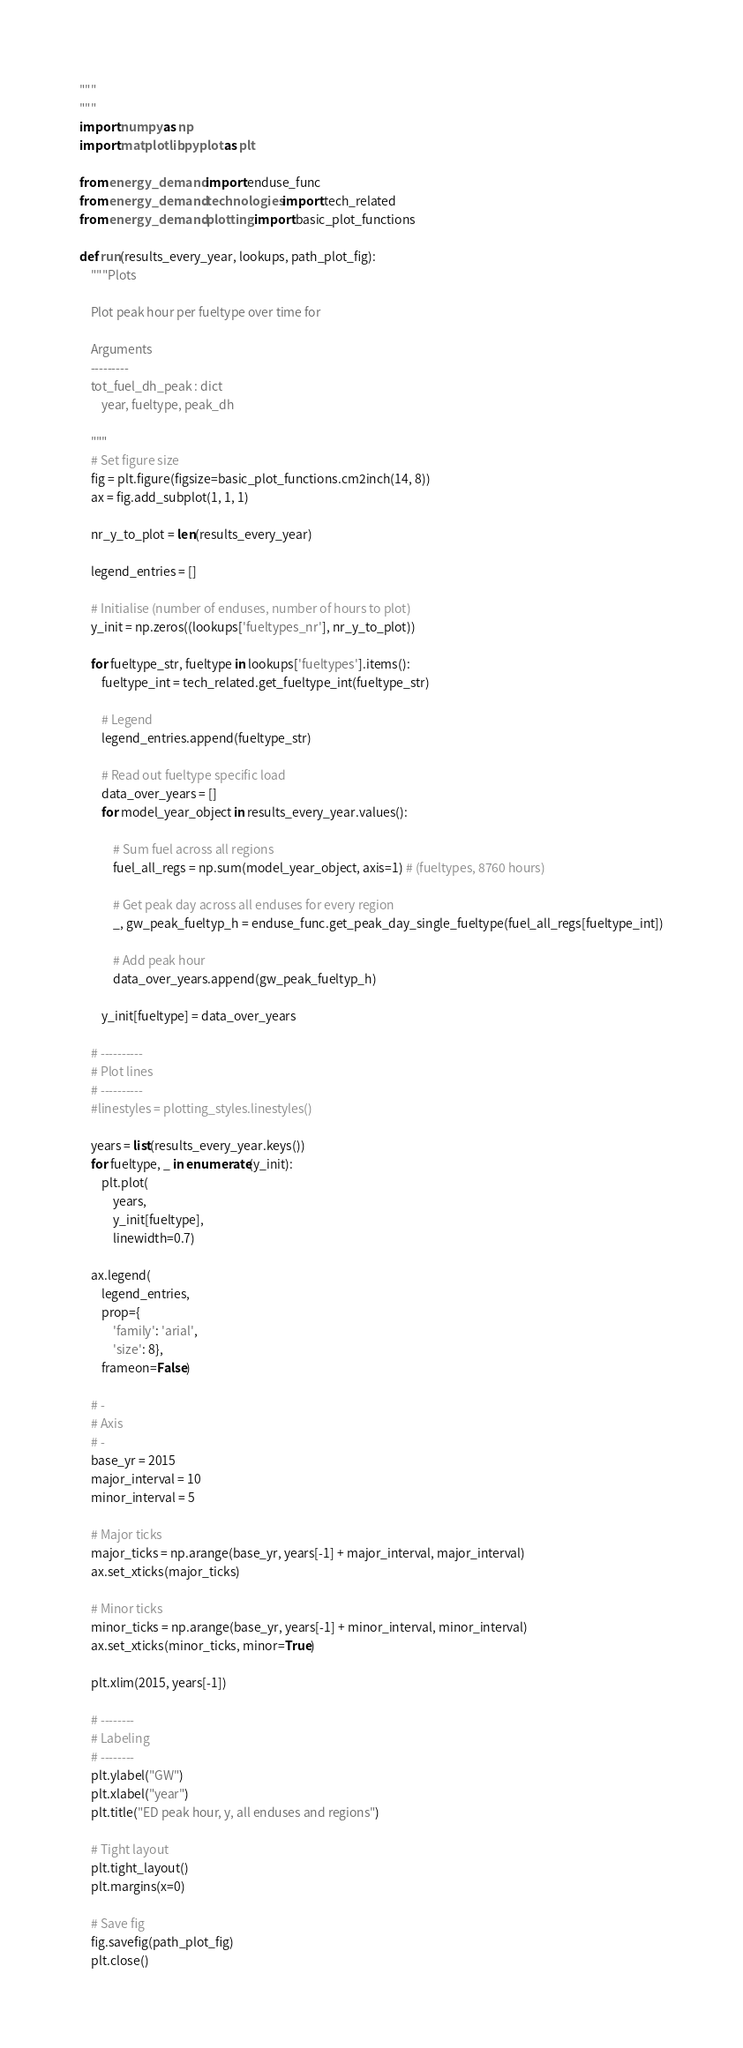Convert code to text. <code><loc_0><loc_0><loc_500><loc_500><_Python_>"""
"""
import numpy as np
import matplotlib.pyplot as plt

from energy_demand import enduse_func
from energy_demand.technologies import tech_related
from energy_demand.plotting import basic_plot_functions

def run(results_every_year, lookups, path_plot_fig):
    """Plots

    Plot peak hour per fueltype over time for

    Arguments
    ---------
    tot_fuel_dh_peak : dict
        year, fueltype, peak_dh

    """
    # Set figure size
    fig = plt.figure(figsize=basic_plot_functions.cm2inch(14, 8))
    ax = fig.add_subplot(1, 1, 1)

    nr_y_to_plot = len(results_every_year)

    legend_entries = []

    # Initialise (number of enduses, number of hours to plot)
    y_init = np.zeros((lookups['fueltypes_nr'], nr_y_to_plot))

    for fueltype_str, fueltype in lookups['fueltypes'].items():
        fueltype_int = tech_related.get_fueltype_int(fueltype_str)

        # Legend
        legend_entries.append(fueltype_str)

        # Read out fueltype specific load
        data_over_years = []
        for model_year_object in results_every_year.values():

            # Sum fuel across all regions
            fuel_all_regs = np.sum(model_year_object, axis=1) # (fueltypes, 8760 hours)

            # Get peak day across all enduses for every region
            _, gw_peak_fueltyp_h = enduse_func.get_peak_day_single_fueltype(fuel_all_regs[fueltype_int])

            # Add peak hour
            data_over_years.append(gw_peak_fueltyp_h)

        y_init[fueltype] = data_over_years

    # ----------
    # Plot lines
    # ----------
    #linestyles = plotting_styles.linestyles()

    years = list(results_every_year.keys())
    for fueltype, _ in enumerate(y_init):
        plt.plot(
            years,
            y_init[fueltype],
            linewidth=0.7)

    ax.legend(
        legend_entries,
        prop={
            'family': 'arial',
            'size': 8},
        frameon=False)

    # -
    # Axis
    # -
    base_yr = 2015
    major_interval = 10
    minor_interval = 5

    # Major ticks
    major_ticks = np.arange(base_yr, years[-1] + major_interval, major_interval)
    ax.set_xticks(major_ticks)

    # Minor ticks
    minor_ticks = np.arange(base_yr, years[-1] + minor_interval, minor_interval)
    ax.set_xticks(minor_ticks, minor=True)

    plt.xlim(2015, years[-1])

    # --------
    # Labeling
    # --------
    plt.ylabel("GW")
    plt.xlabel("year")
    plt.title("ED peak hour, y, all enduses and regions")

    # Tight layout
    plt.tight_layout()
    plt.margins(x=0)

    # Save fig
    fig.savefig(path_plot_fig)
    plt.close()
</code> 